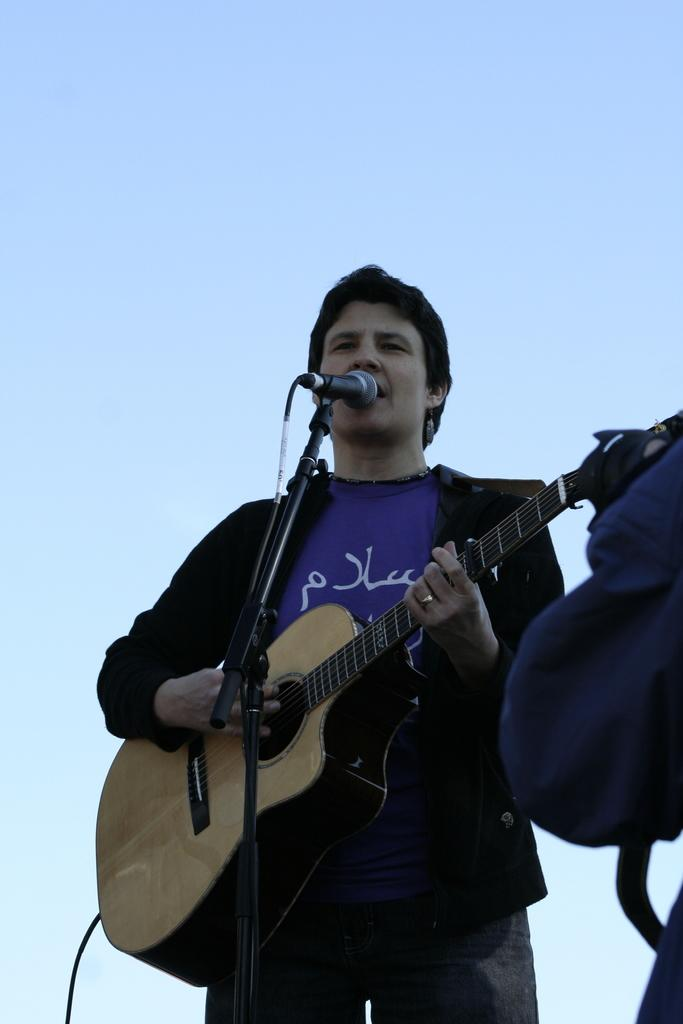What is the main subject of the image? There is a person in the image. What is the person doing in the image? The person is standing in front of a microphone and singing while playing a guitar. What can be seen in the background of the image? The sky is visible in the image. How would you describe the weather based on the image? The sky appears to be clear, suggesting good weather. How many tomatoes are on the person's head in the image? There are no tomatoes present in the image. Can you see any mice running around the person's feet in the image? There are no mice visible in the image. 